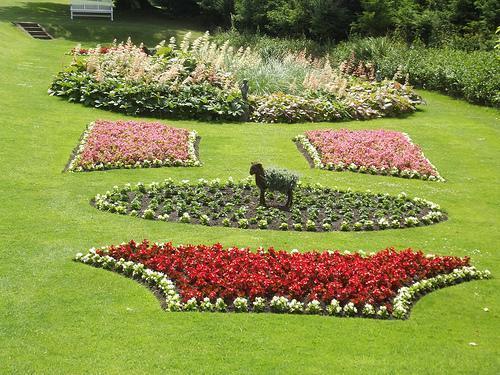How many benches are there?
Give a very brief answer. 1. 